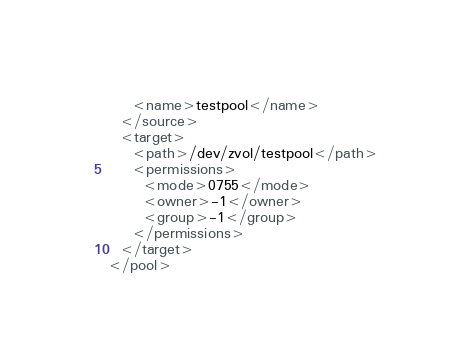<code> <loc_0><loc_0><loc_500><loc_500><_XML_>    <name>testpool</name>
  </source>
  <target>
    <path>/dev/zvol/testpool</path>
    <permissions>
      <mode>0755</mode>
      <owner>-1</owner>
      <group>-1</group>
    </permissions>
  </target>
</pool>
</code> 